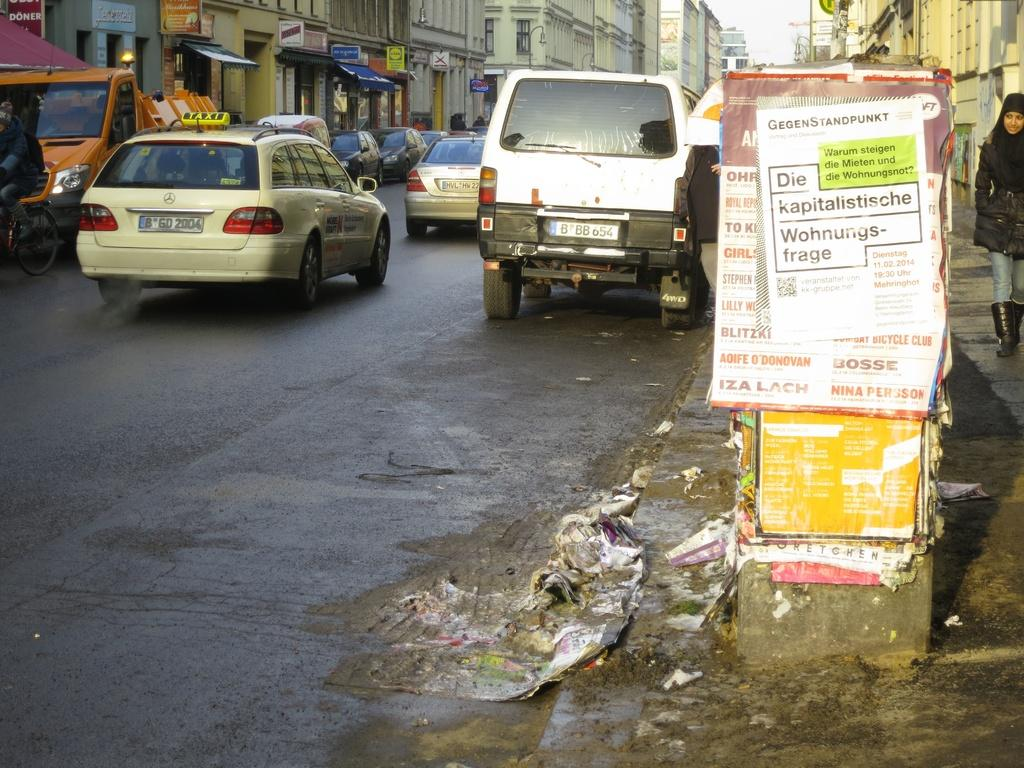Provide a one-sentence caption for the provided image. A busy street has a sign that says Die kapitalistische Wohnungs-frage. 